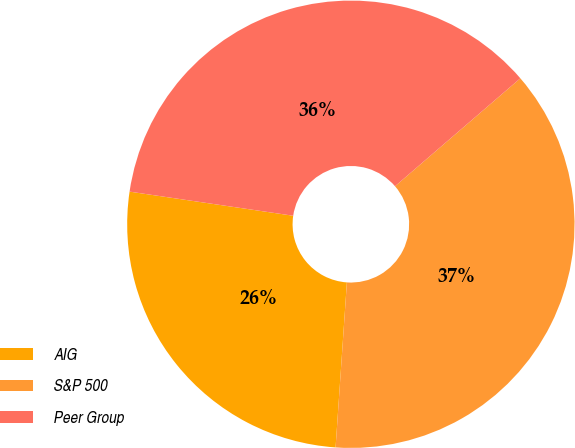Convert chart to OTSL. <chart><loc_0><loc_0><loc_500><loc_500><pie_chart><fcel>AIG<fcel>S&P 500<fcel>Peer Group<nl><fcel>26.24%<fcel>37.4%<fcel>36.35%<nl></chart> 